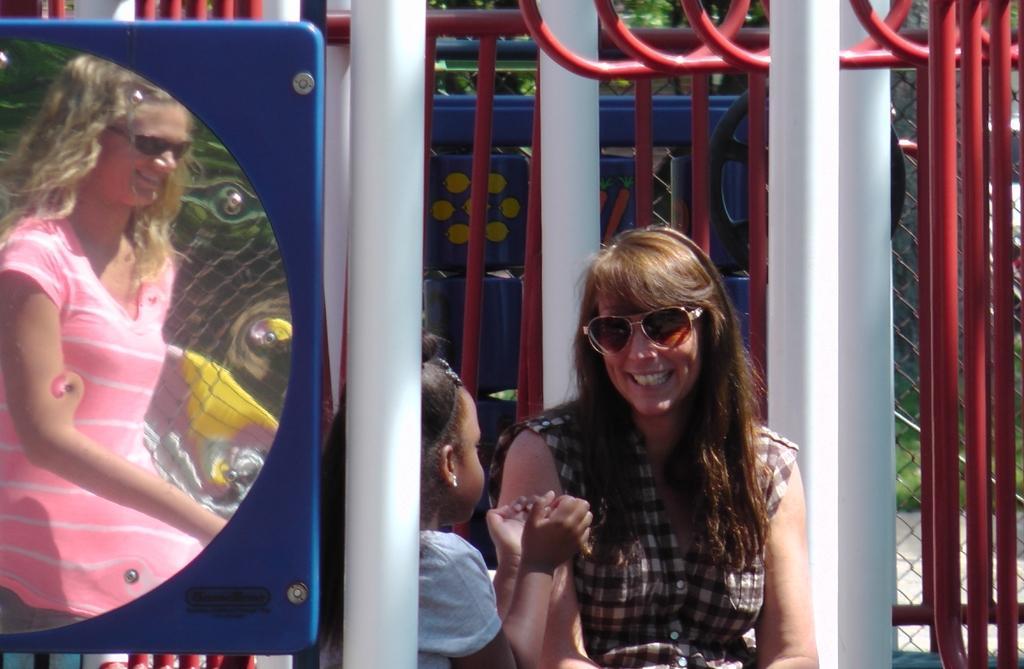Can you describe this image briefly? In this image we can see a mirror attached to the fence through which we can see a woman wearing pink dress and glasses is smiling. Here we can see a child and a woman wearing glasses is smiling. In the background, we can see a net, red color poles and trees. 